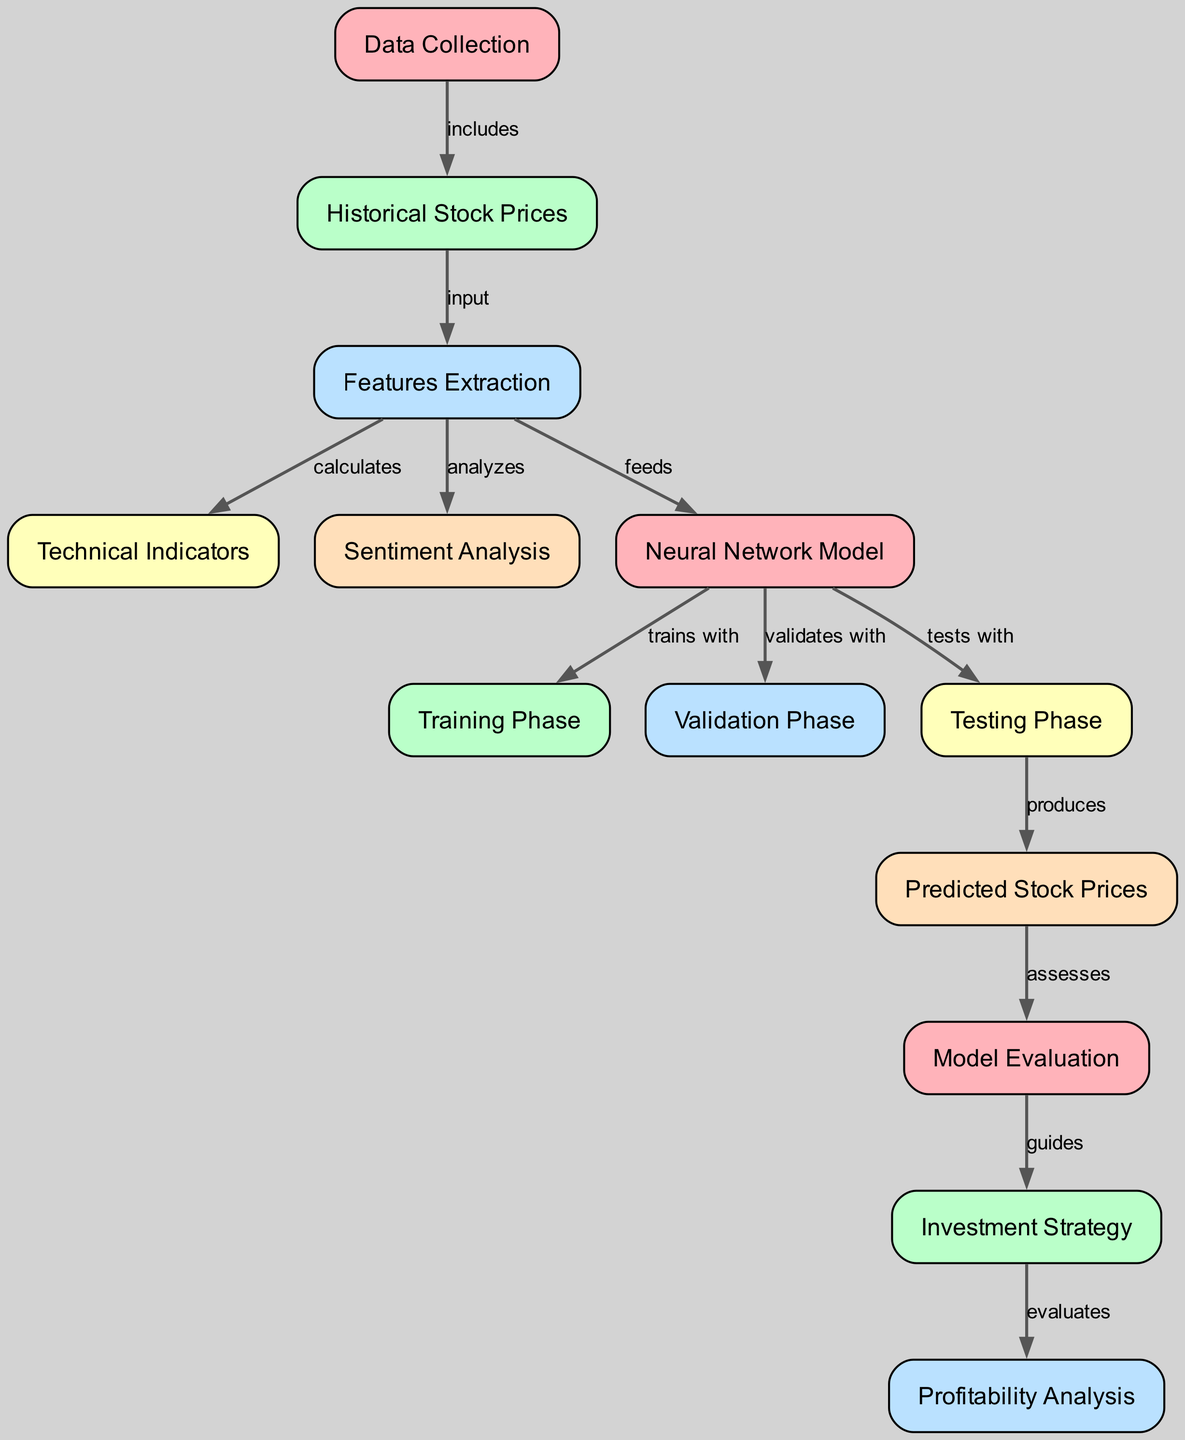What is the total number of nodes in the diagram? The diagram lists several nodes related to neural network analysis for predicting stock market trends. By counting each individual node from the provided data, we find that there are a total of 13 nodes.
Answer: 13 Which node follows the "Technical Indicators" node? The "Technical Indicators" node is connected to the "Sentiment Analysis" and "Neural Network Model" nodes. By examining the diagram, we see that it leads to the "Neural Network Model" node in the sequence.
Answer: Neural Network Model What is the relationship between "Sentiment Analysis" and "Neural Network Model"? The diagram specifies that "Sentiment Analysis" analyzes the data, which is then fed into the "Neural Network Model". Thus, the relationship can be described as a data feeding or input relationship.
Answer: analyzes In which phase do we assess the "Predicted Stock Prices"? Following the flow in the diagram, the "Predicted Stock Prices" node is assessed in the "Model Evaluation" phase. This is shown by the direct connection from "Predicted Stock Prices" to "Model Evaluation".
Answer: Model Evaluation How many edges are there in the diagram? Each connection between nodes represents an edge. Counting all the edges specified in the diagram data, we determine that there are 12 edges within the diagram.
Answer: 12 What phase directly follows the "Training Phase"? According to the diagram's flow, the "Validation Phase" directly follows the "Training Phase". This indicates a sequential progression in the analysis process of the neural network model.
Answer: Validation Phase What comes after the "Testing Phase"? The result of the "Testing Phase" produces "Predicted Stock Prices", meaning "Predicted Stock Prices" is the next step in the flow after "Testing Phase".
Answer: Predicted Stock Prices What guides the "Investment Strategy"? The "Model Evaluation" phase provides guidance to the "Investment Strategy". This relationship is directly indicated by the flow from "Model Evaluation" to "Investment Strategy".
Answer: Model Evaluation What does the "Profitability Analysis" evaluate? The diagram demonstrates that the "Profitability Analysis" evaluates the outcomes derived from the "Investment Strategy". The evaluation is indicated by the direct connection from "Investment Strategy" to "Profitability Analysis".
Answer: Investment Strategy 